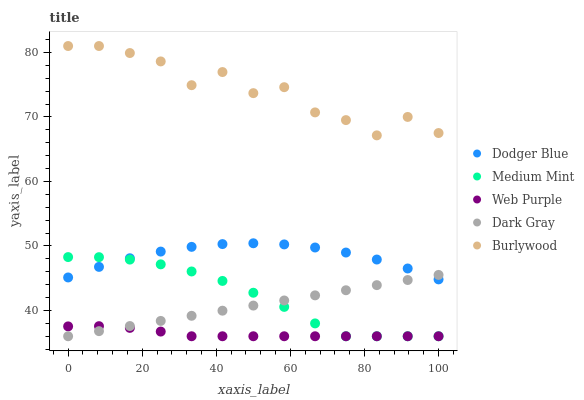Does Web Purple have the minimum area under the curve?
Answer yes or no. Yes. Does Burlywood have the maximum area under the curve?
Answer yes or no. Yes. Does Dark Gray have the minimum area under the curve?
Answer yes or no. No. Does Dark Gray have the maximum area under the curve?
Answer yes or no. No. Is Dark Gray the smoothest?
Answer yes or no. Yes. Is Burlywood the roughest?
Answer yes or no. Yes. Is Web Purple the smoothest?
Answer yes or no. No. Is Web Purple the roughest?
Answer yes or no. No. Does Medium Mint have the lowest value?
Answer yes or no. Yes. Does Dodger Blue have the lowest value?
Answer yes or no. No. Does Burlywood have the highest value?
Answer yes or no. Yes. Does Dark Gray have the highest value?
Answer yes or no. No. Is Web Purple less than Dodger Blue?
Answer yes or no. Yes. Is Burlywood greater than Dark Gray?
Answer yes or no. Yes. Does Dodger Blue intersect Dark Gray?
Answer yes or no. Yes. Is Dodger Blue less than Dark Gray?
Answer yes or no. No. Is Dodger Blue greater than Dark Gray?
Answer yes or no. No. Does Web Purple intersect Dodger Blue?
Answer yes or no. No. 